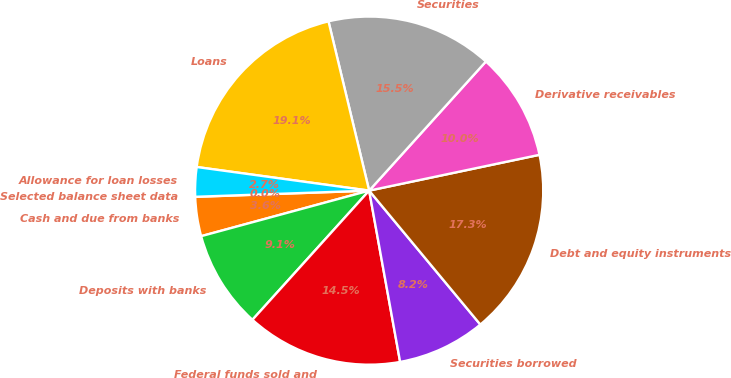Convert chart to OTSL. <chart><loc_0><loc_0><loc_500><loc_500><pie_chart><fcel>Selected balance sheet data<fcel>Cash and due from banks<fcel>Deposits with banks<fcel>Federal funds sold and<fcel>Securities borrowed<fcel>Debt and equity instruments<fcel>Derivative receivables<fcel>Securities<fcel>Loans<fcel>Allowance for loan losses<nl><fcel>0.01%<fcel>3.64%<fcel>9.09%<fcel>14.54%<fcel>8.18%<fcel>17.27%<fcel>10.0%<fcel>15.45%<fcel>19.08%<fcel>2.73%<nl></chart> 